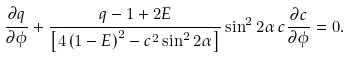<formula> <loc_0><loc_0><loc_500><loc_500>\frac { \partial q } { \partial \phi } + \frac { q - 1 + 2 E } { \left [ 4 \left ( 1 - E \right ) ^ { 2 } - c ^ { 2 } \sin ^ { 2 } 2 \alpha \right ] } \sin ^ { 2 } 2 \alpha \, c \frac { \partial c } { \partial \phi } = 0 .</formula> 